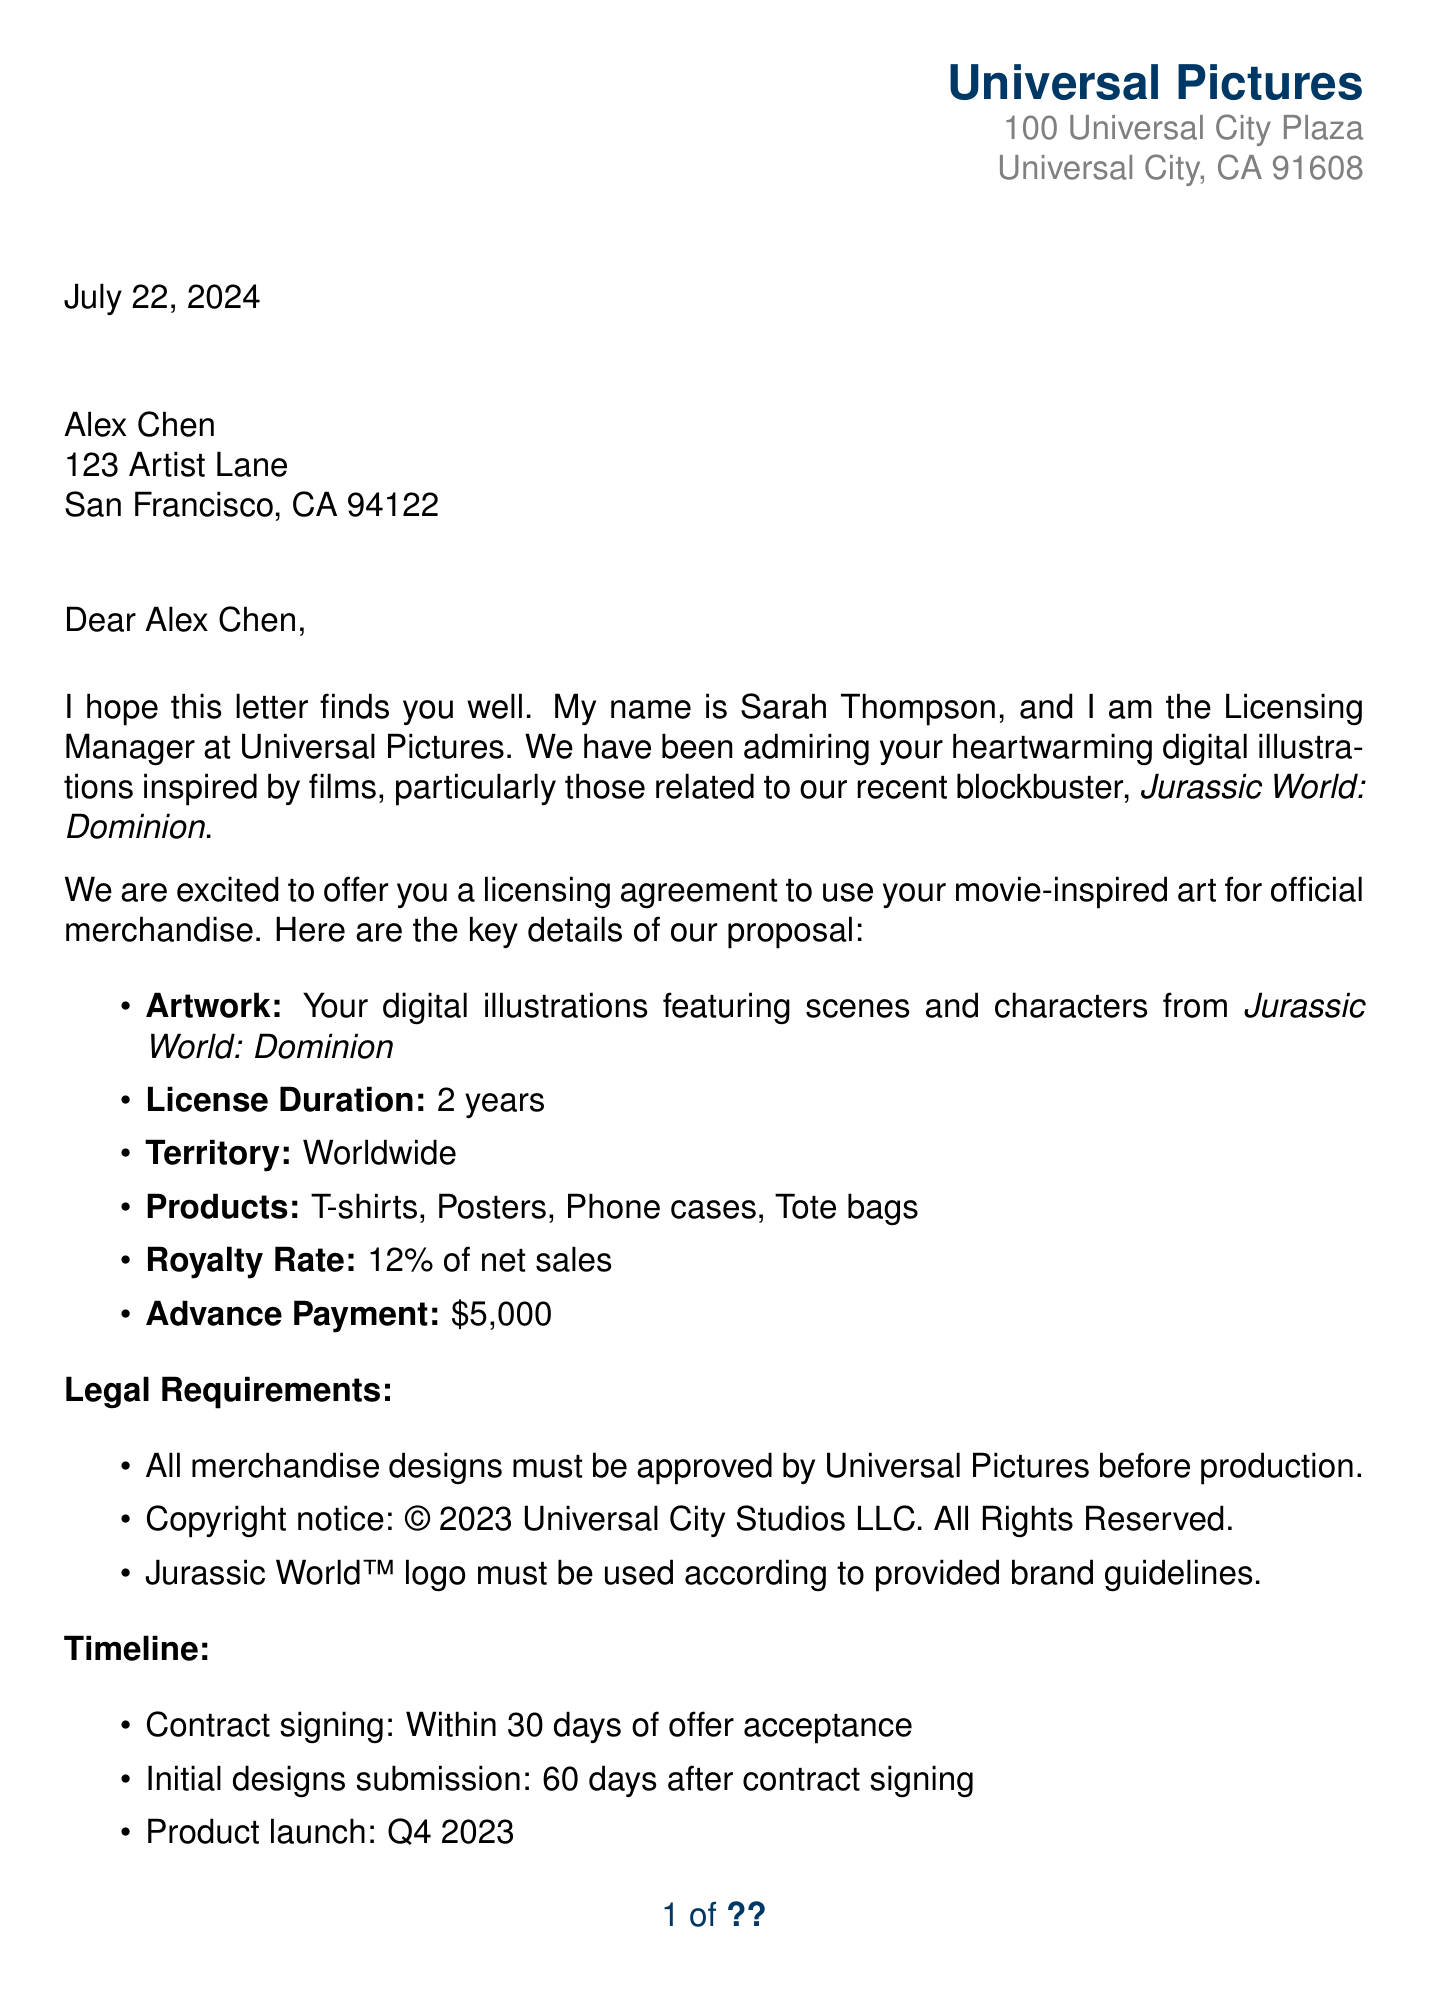What is the name of the Licensing Manager? The Licensing Manager's name is Sarah Thompson, as stated in the sender's information section of the document.
Answer: Sarah Thompson What is the royalty rate offered in the licensing agreement? The document specifies that the royalty rate is 12% of net sales.
Answer: 12% What is the advance payment amount for the licensing agreement? The document clearly states that the advance payment is $5,000.
Answer: $5,000 How long is the licensing duration? According to the proposal, the licensing duration is for 2 years.
Answer: 2 years What is the product launch timeline specified in the document? The timeline indicates the product launch is scheduled for Q4 2023.
Answer: Q4 2023 Who should the recipient contact for questions? The document mentions that Michael Roberts is the contact person for questions.
Answer: Michael Roberts What type of merchandise is included in the licensing agreement? The document lists T-shirts, Posters, Phone cases, and Tote bags as part of the merchandise.
Answer: T-shirts, Posters, Phone cases, Tote bags What must happen for merchandise designs to proceed? According to the legal requirements, all merchandise designs must be approved by Universal Pictures before production.
Answer: Approved by Universal Pictures What social media feature opportunity is mentioned? The document includes the possibility of being featured on Universal Pictures' social media channels.
Answer: Featured on social media channels 